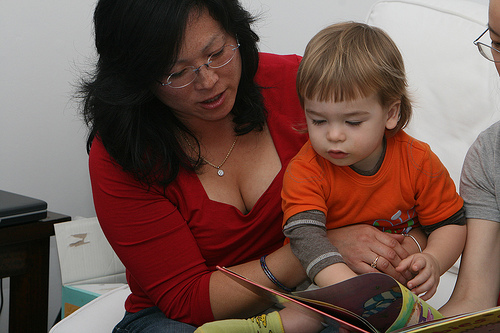<image>
Can you confirm if the woman is in front of the child? No. The woman is not in front of the child. The spatial positioning shows a different relationship between these objects. 